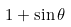<formula> <loc_0><loc_0><loc_500><loc_500>1 + \sin \theta</formula> 